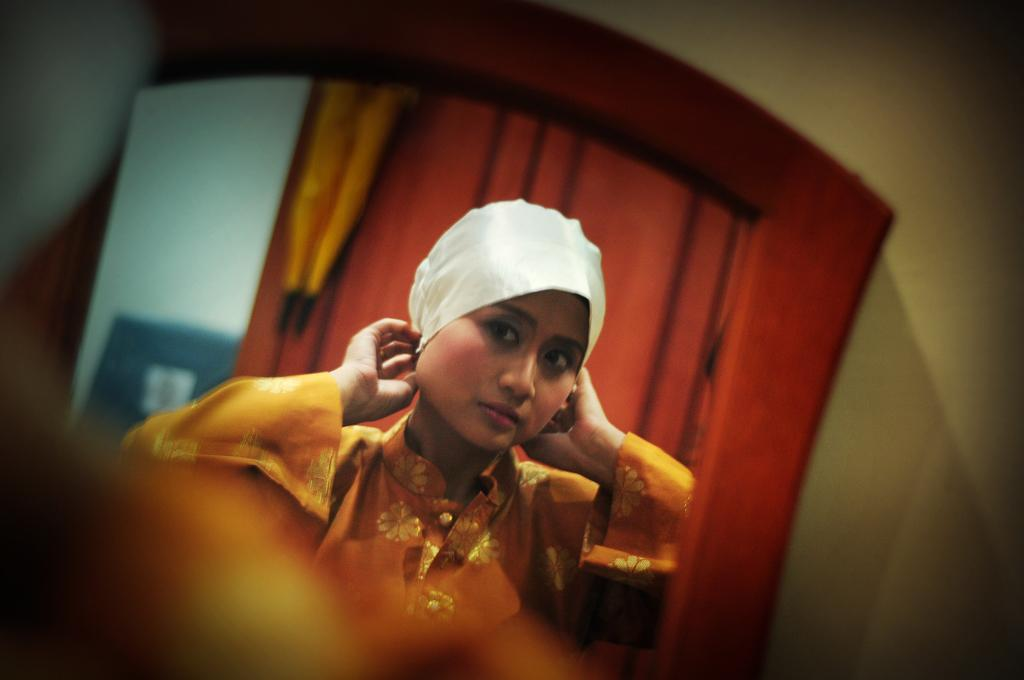What object is located in the center of the image? There is a mirror in the center of the image. Can you describe the position of the mirror in the image? The mirror is in the center of the image. What can be seen in the mirror? There is a girl in front of a curtain in the mirror. What type of silverware is visible in the image? There is no silverware present in the image. Can you describe the houses in the background of the image? There are no houses visible in the image; it only features a mirror with a girl in front of a curtain. 